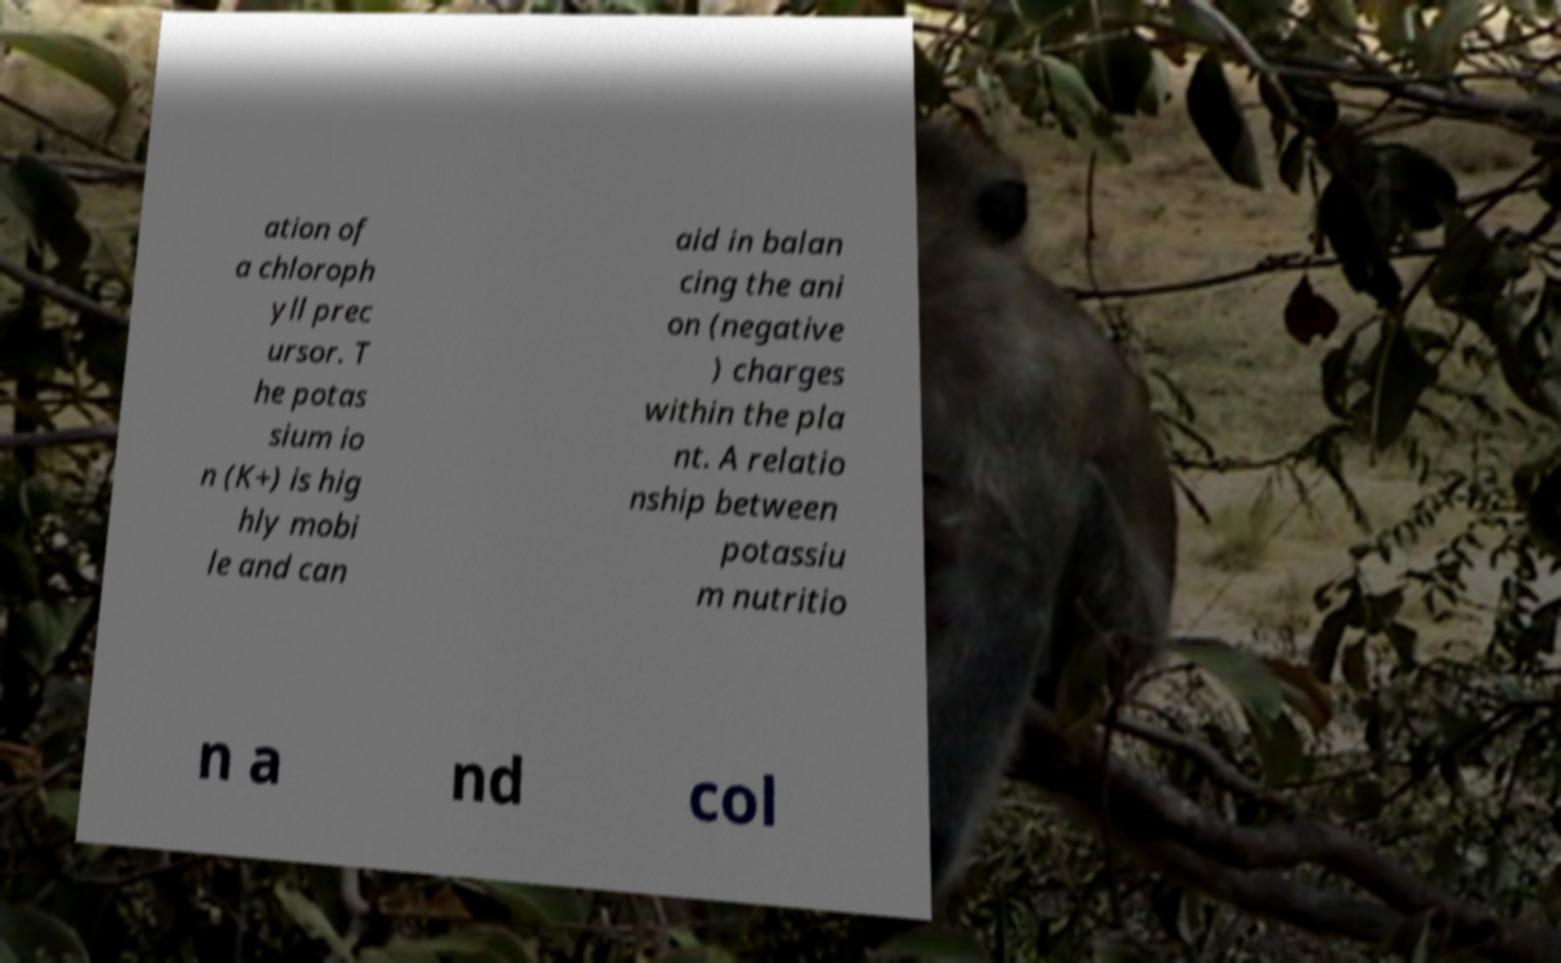Please read and relay the text visible in this image. What does it say? ation of a chloroph yll prec ursor. T he potas sium io n (K+) is hig hly mobi le and can aid in balan cing the ani on (negative ) charges within the pla nt. A relatio nship between potassiu m nutritio n a nd col 